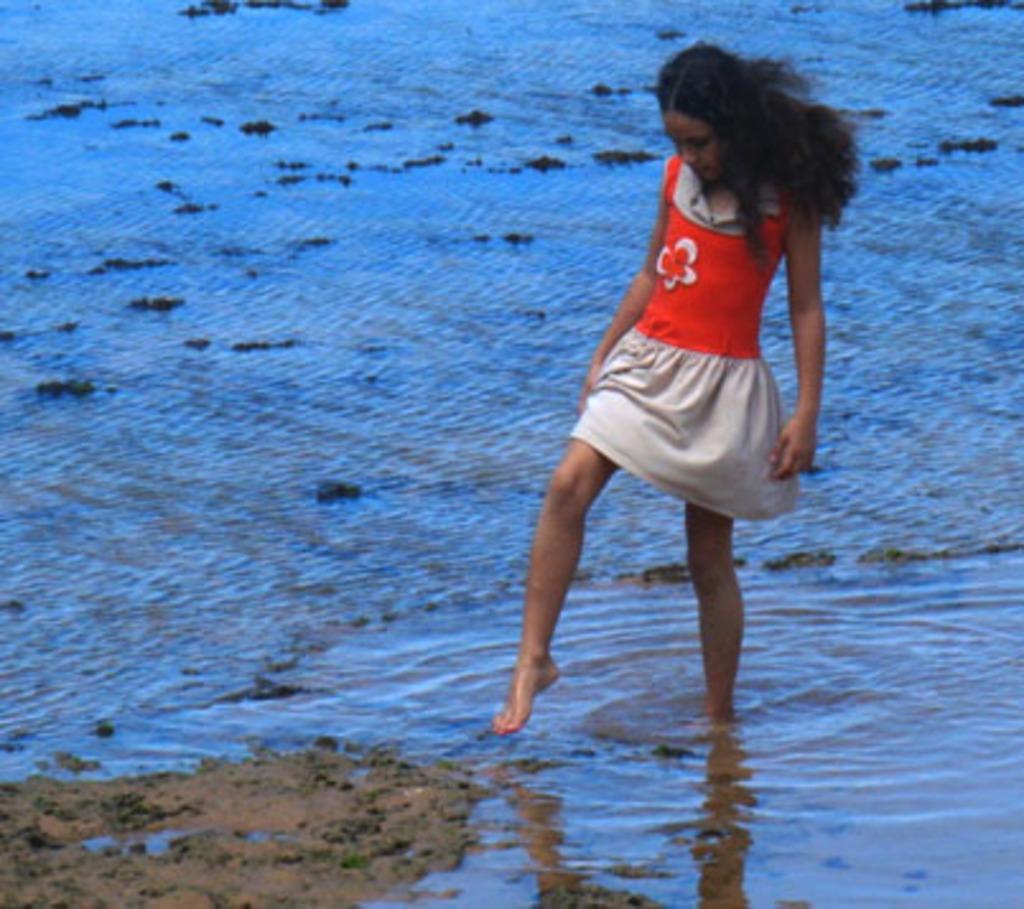Describe this image in one or two sentences. In this picture there is a girl who is wearing red and grey color dress. She is standing on the water. In the bottom left corner I can see the land. 